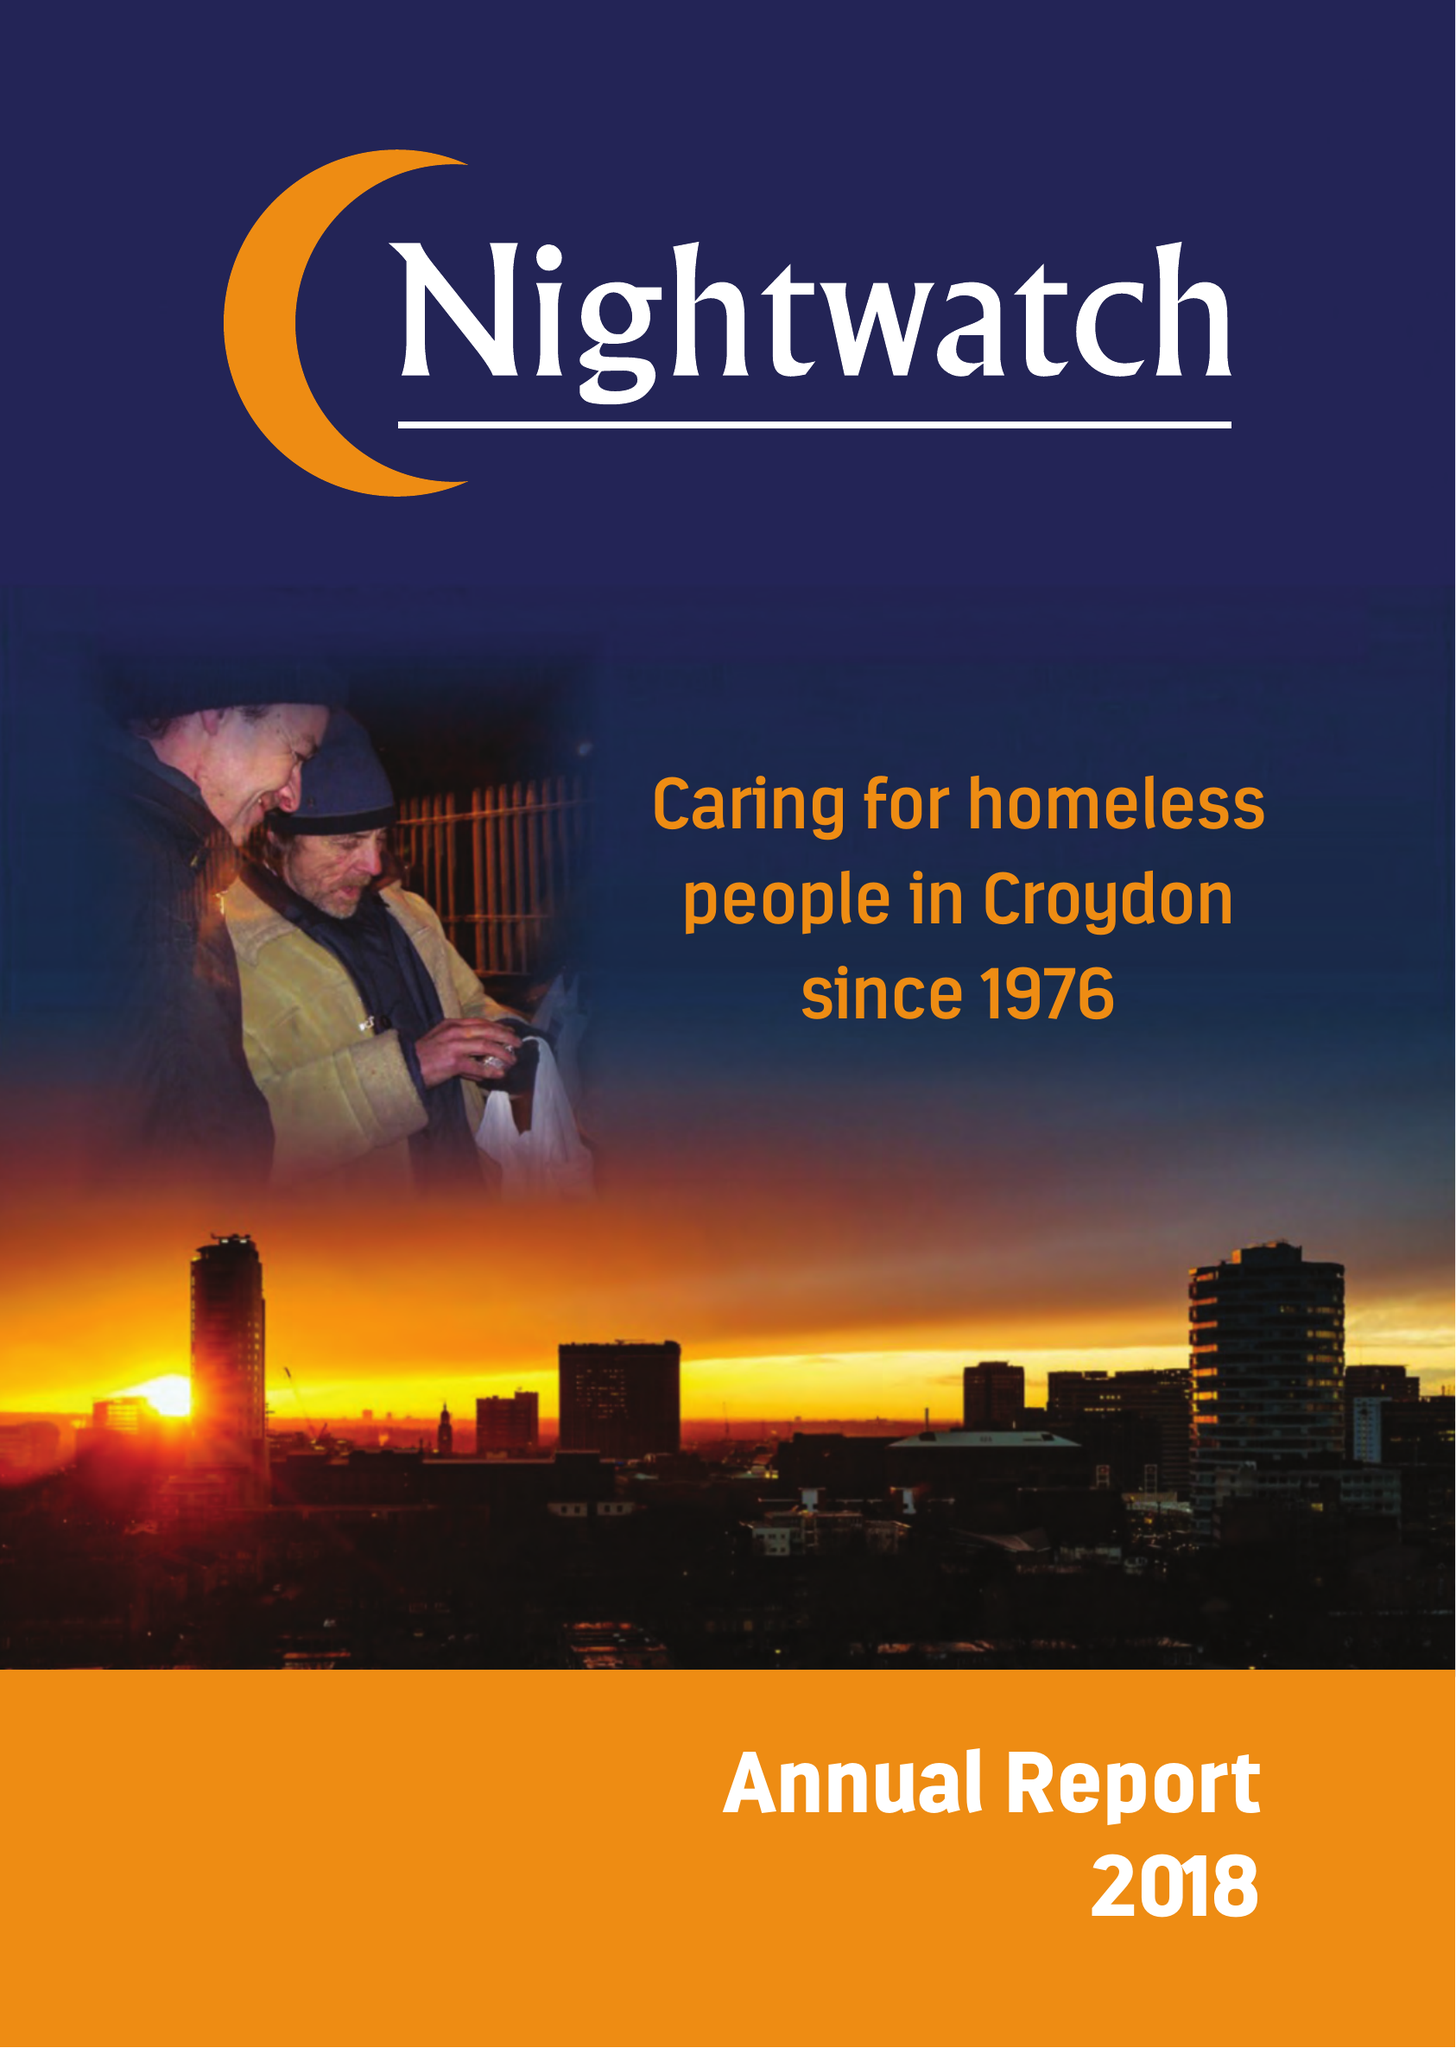What is the value for the report_date?
Answer the question using a single word or phrase. 2017-12-31 